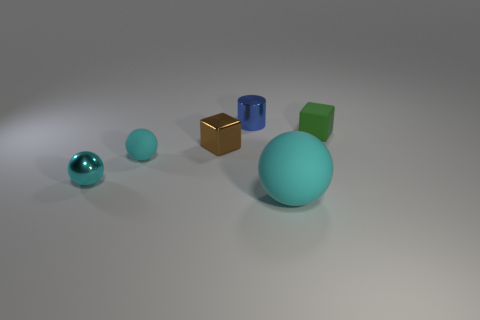Subtract all rubber spheres. How many spheres are left? 1 Add 3 green matte blocks. How many objects exist? 9 Add 2 cyan metal blocks. How many cyan metal blocks exist? 2 Subtract 1 brown blocks. How many objects are left? 5 Subtract all cubes. How many objects are left? 4 Subtract 1 blocks. How many blocks are left? 1 Subtract all cyan blocks. Subtract all purple spheres. How many blocks are left? 2 Subtract all purple cubes. How many purple cylinders are left? 0 Subtract all blue things. Subtract all large purple rubber objects. How many objects are left? 5 Add 5 tiny balls. How many tiny balls are left? 7 